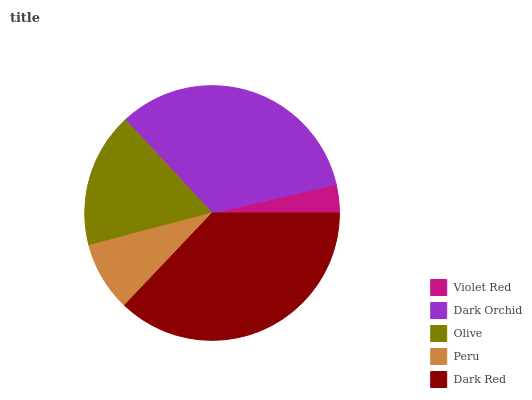Is Violet Red the minimum?
Answer yes or no. Yes. Is Dark Red the maximum?
Answer yes or no. Yes. Is Dark Orchid the minimum?
Answer yes or no. No. Is Dark Orchid the maximum?
Answer yes or no. No. Is Dark Orchid greater than Violet Red?
Answer yes or no. Yes. Is Violet Red less than Dark Orchid?
Answer yes or no. Yes. Is Violet Red greater than Dark Orchid?
Answer yes or no. No. Is Dark Orchid less than Violet Red?
Answer yes or no. No. Is Olive the high median?
Answer yes or no. Yes. Is Olive the low median?
Answer yes or no. Yes. Is Dark Red the high median?
Answer yes or no. No. Is Peru the low median?
Answer yes or no. No. 